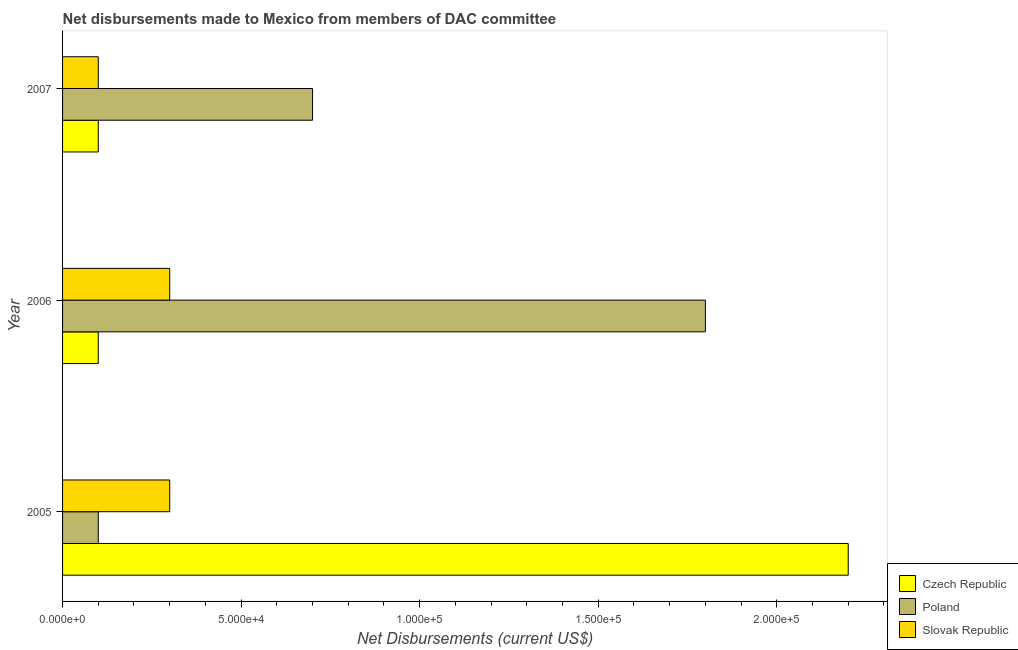How many different coloured bars are there?
Make the answer very short. 3. Are the number of bars on each tick of the Y-axis equal?
Keep it short and to the point. Yes. How many bars are there on the 3rd tick from the top?
Offer a very short reply. 3. How many bars are there on the 1st tick from the bottom?
Offer a very short reply. 3. What is the net disbursements made by poland in 2006?
Give a very brief answer. 1.80e+05. Across all years, what is the maximum net disbursements made by slovak republic?
Your answer should be very brief. 3.00e+04. Across all years, what is the minimum net disbursements made by czech republic?
Provide a short and direct response. 10000. In which year was the net disbursements made by slovak republic maximum?
Offer a terse response. 2005. What is the total net disbursements made by poland in the graph?
Give a very brief answer. 2.60e+05. What is the difference between the net disbursements made by czech republic in 2005 and that in 2007?
Your response must be concise. 2.10e+05. What is the difference between the net disbursements made by poland in 2006 and the net disbursements made by slovak republic in 2005?
Provide a succinct answer. 1.50e+05. What is the average net disbursements made by slovak republic per year?
Provide a succinct answer. 2.33e+04. In the year 2007, what is the difference between the net disbursements made by slovak republic and net disbursements made by poland?
Provide a succinct answer. -6.00e+04. What is the ratio of the net disbursements made by poland in 2006 to that in 2007?
Provide a succinct answer. 2.57. Is the net disbursements made by poland in 2005 less than that in 2006?
Offer a very short reply. Yes. What is the difference between the highest and the second highest net disbursements made by czech republic?
Keep it short and to the point. 2.10e+05. What is the difference between the highest and the lowest net disbursements made by poland?
Offer a very short reply. 1.70e+05. Is the sum of the net disbursements made by czech republic in 2006 and 2007 greater than the maximum net disbursements made by poland across all years?
Provide a succinct answer. No. What does the 2nd bar from the top in 2005 represents?
Give a very brief answer. Poland. Are all the bars in the graph horizontal?
Make the answer very short. Yes. How many years are there in the graph?
Your answer should be very brief. 3. What is the difference between two consecutive major ticks on the X-axis?
Provide a succinct answer. 5.00e+04. Does the graph contain grids?
Provide a succinct answer. No. Where does the legend appear in the graph?
Give a very brief answer. Bottom right. How are the legend labels stacked?
Keep it short and to the point. Vertical. What is the title of the graph?
Offer a terse response. Net disbursements made to Mexico from members of DAC committee. Does "Taxes" appear as one of the legend labels in the graph?
Your response must be concise. No. What is the label or title of the X-axis?
Your answer should be compact. Net Disbursements (current US$). What is the Net Disbursements (current US$) in Czech Republic in 2005?
Provide a succinct answer. 2.20e+05. What is the Net Disbursements (current US$) in Poland in 2005?
Provide a short and direct response. 10000. What is the Net Disbursements (current US$) of Czech Republic in 2006?
Your answer should be very brief. 10000. What is the Net Disbursements (current US$) of Slovak Republic in 2007?
Offer a terse response. 10000. Across all years, what is the minimum Net Disbursements (current US$) of Czech Republic?
Offer a very short reply. 10000. What is the difference between the Net Disbursements (current US$) in Czech Republic in 2005 and that in 2006?
Offer a very short reply. 2.10e+05. What is the difference between the Net Disbursements (current US$) in Poland in 2005 and that in 2006?
Give a very brief answer. -1.70e+05. What is the difference between the Net Disbursements (current US$) in Slovak Republic in 2005 and that in 2006?
Your response must be concise. 0. What is the difference between the Net Disbursements (current US$) in Poland in 2005 and that in 2007?
Provide a short and direct response. -6.00e+04. What is the difference between the Net Disbursements (current US$) of Slovak Republic in 2005 and that in 2007?
Offer a terse response. 2.00e+04. What is the difference between the Net Disbursements (current US$) in Czech Republic in 2006 and that in 2007?
Keep it short and to the point. 0. What is the difference between the Net Disbursements (current US$) of Czech Republic in 2005 and the Net Disbursements (current US$) of Poland in 2006?
Your answer should be very brief. 4.00e+04. What is the difference between the Net Disbursements (current US$) in Czech Republic in 2005 and the Net Disbursements (current US$) in Slovak Republic in 2006?
Offer a terse response. 1.90e+05. What is the difference between the Net Disbursements (current US$) of Poland in 2005 and the Net Disbursements (current US$) of Slovak Republic in 2006?
Offer a very short reply. -2.00e+04. What is the difference between the Net Disbursements (current US$) of Czech Republic in 2005 and the Net Disbursements (current US$) of Poland in 2007?
Provide a short and direct response. 1.50e+05. What is the difference between the Net Disbursements (current US$) of Czech Republic in 2006 and the Net Disbursements (current US$) of Poland in 2007?
Provide a short and direct response. -6.00e+04. What is the average Net Disbursements (current US$) in Czech Republic per year?
Ensure brevity in your answer.  8.00e+04. What is the average Net Disbursements (current US$) of Poland per year?
Offer a very short reply. 8.67e+04. What is the average Net Disbursements (current US$) of Slovak Republic per year?
Your response must be concise. 2.33e+04. In the year 2005, what is the difference between the Net Disbursements (current US$) of Czech Republic and Net Disbursements (current US$) of Slovak Republic?
Make the answer very short. 1.90e+05. In the year 2006, what is the difference between the Net Disbursements (current US$) of Czech Republic and Net Disbursements (current US$) of Poland?
Make the answer very short. -1.70e+05. In the year 2006, what is the difference between the Net Disbursements (current US$) of Czech Republic and Net Disbursements (current US$) of Slovak Republic?
Give a very brief answer. -2.00e+04. In the year 2007, what is the difference between the Net Disbursements (current US$) of Poland and Net Disbursements (current US$) of Slovak Republic?
Your answer should be very brief. 6.00e+04. What is the ratio of the Net Disbursements (current US$) of Poland in 2005 to that in 2006?
Your answer should be very brief. 0.06. What is the ratio of the Net Disbursements (current US$) in Czech Republic in 2005 to that in 2007?
Give a very brief answer. 22. What is the ratio of the Net Disbursements (current US$) of Poland in 2005 to that in 2007?
Make the answer very short. 0.14. What is the ratio of the Net Disbursements (current US$) in Slovak Republic in 2005 to that in 2007?
Ensure brevity in your answer.  3. What is the ratio of the Net Disbursements (current US$) in Czech Republic in 2006 to that in 2007?
Your answer should be very brief. 1. What is the ratio of the Net Disbursements (current US$) in Poland in 2006 to that in 2007?
Offer a terse response. 2.57. What is the difference between the highest and the second highest Net Disbursements (current US$) of Czech Republic?
Provide a short and direct response. 2.10e+05. What is the difference between the highest and the second highest Net Disbursements (current US$) in Slovak Republic?
Provide a short and direct response. 0. What is the difference between the highest and the lowest Net Disbursements (current US$) in Poland?
Give a very brief answer. 1.70e+05. 